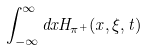<formula> <loc_0><loc_0><loc_500><loc_500>\int _ { - \infty } ^ { \infty } d x H _ { \pi ^ { + } } ( x , \xi , t )</formula> 